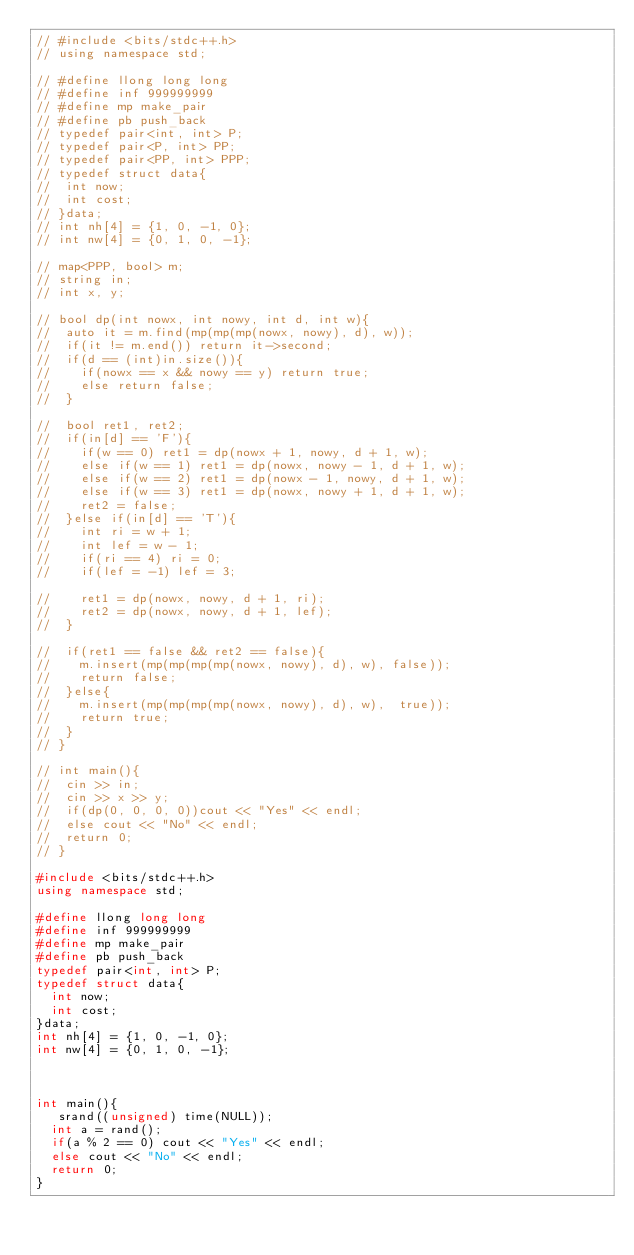Convert code to text. <code><loc_0><loc_0><loc_500><loc_500><_C++_>// #include <bits/stdc++.h>
// using namespace std;

// #define llong long long
// #define inf 999999999
// #define mp make_pair
// #define pb push_back
// typedef pair<int, int> P;
// typedef pair<P, int> PP;
// typedef pair<PP, int> PPP;
// typedef struct data{
// 	int now;
// 	int cost;
// }data;
// int nh[4] = {1, 0, -1, 0};
// int nw[4] = {0, 1, 0, -1};

// map<PPP, bool> m;
// string in;
// int x, y;

// bool dp(int nowx, int nowy, int d, int w){
// 	auto it = m.find(mp(mp(mp(nowx, nowy), d), w));
// 	if(it != m.end()) return it->second;
// 	if(d == (int)in.size()){
// 		if(nowx == x && nowy == y) return true;
// 		else return false;
// 	}

// 	bool ret1, ret2;
// 	if(in[d] == 'F'){
// 		if(w == 0) ret1 = dp(nowx + 1, nowy, d + 1, w);
// 		else if(w == 1) ret1 = dp(nowx, nowy - 1, d + 1, w);
// 		else if(w == 2) ret1 = dp(nowx - 1, nowy, d + 1, w);
// 		else if(w == 3) ret1 = dp(nowx, nowy + 1, d + 1, w);
// 		ret2 = false;
// 	}else if(in[d] == 'T'){
// 		int ri = w + 1;
// 		int lef = w - 1;
// 		if(ri == 4) ri = 0;
// 		if(lef = -1) lef = 3;

// 		ret1 = dp(nowx, nowy, d + 1, ri);
// 		ret2 = dp(nowx, nowy, d + 1, lef);
// 	}

// 	if(ret1 == false && ret2 == false){
// 		m.insert(mp(mp(mp(mp(nowx, nowy), d), w), false));
// 		return false;
// 	}else{
// 		m.insert(mp(mp(mp(mp(nowx, nowy), d), w),  true));
// 		return true;
// 	}
// }

// int main(){
// 	cin >> in;
// 	cin >> x >> y;
// 	if(dp(0, 0, 0, 0))cout << "Yes" << endl;
// 	else cout << "No" << endl;
// 	return 0;
// }

#include <bits/stdc++.h>
using namespace std;

#define llong long long
#define inf 999999999
#define mp make_pair
#define pb push_back
typedef pair<int, int> P;
typedef struct data{
	int now;
	int cost;
}data;
int nh[4] = {1, 0, -1, 0};
int nw[4] = {0, 1, 0, -1};



int main(){
	 srand((unsigned) time(NULL));
	int a = rand();
	if(a % 2 == 0) cout << "Yes" << endl;
	else cout << "No" << endl;
	return 0;	
}</code> 